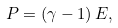<formula> <loc_0><loc_0><loc_500><loc_500>P = ( \gamma - 1 ) \, E ,</formula> 